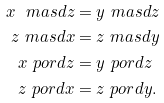Convert formula to latex. <formula><loc_0><loc_0><loc_500><loc_500>x \ m a s d z & = y \ m a s d z \\ z \ m a s d x & = z \ m a s d y \\ x \ p o r d z & = y \ p o r d z \\ z \ p o r d x & = z \ p o r d y .</formula> 